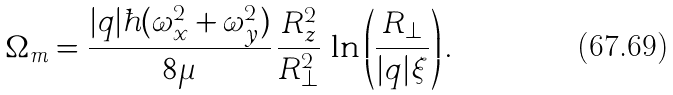Convert formula to latex. <formula><loc_0><loc_0><loc_500><loc_500>\Omega _ { m } = \frac { | q | \hbar { ( } \omega _ { x } ^ { 2 } + \omega _ { y } ^ { 2 } ) } { 8 \mu } \, \frac { R _ { z } ^ { 2 } } { R _ { \perp } ^ { 2 } } \, \ln \left ( \frac { R _ { \perp } } { | q | \xi } \right ) .</formula> 